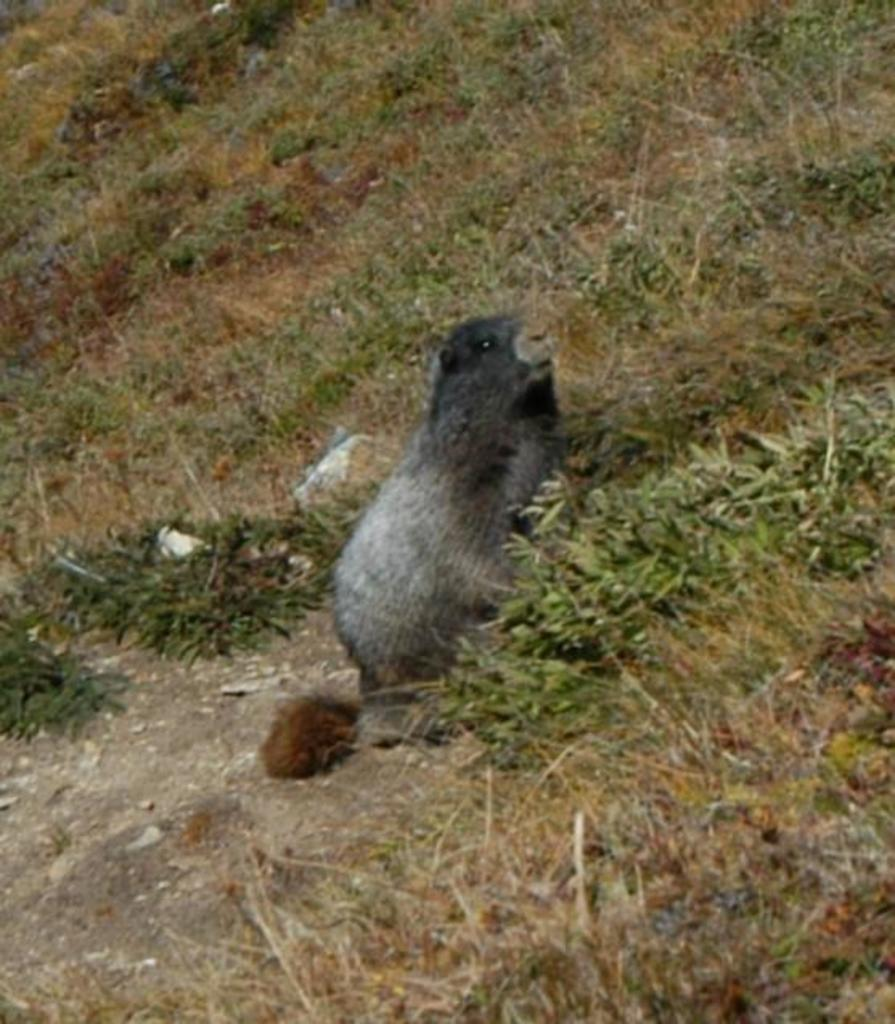What type of surface is visible in the image? There is a grass surface in the image. Is there any living creature on the grass surface? Yes, there is an animal on the grass surface. What type of houses can be seen in the background of the image? There is no background or houses visible in the image; it only features a grass surface and an animal. 